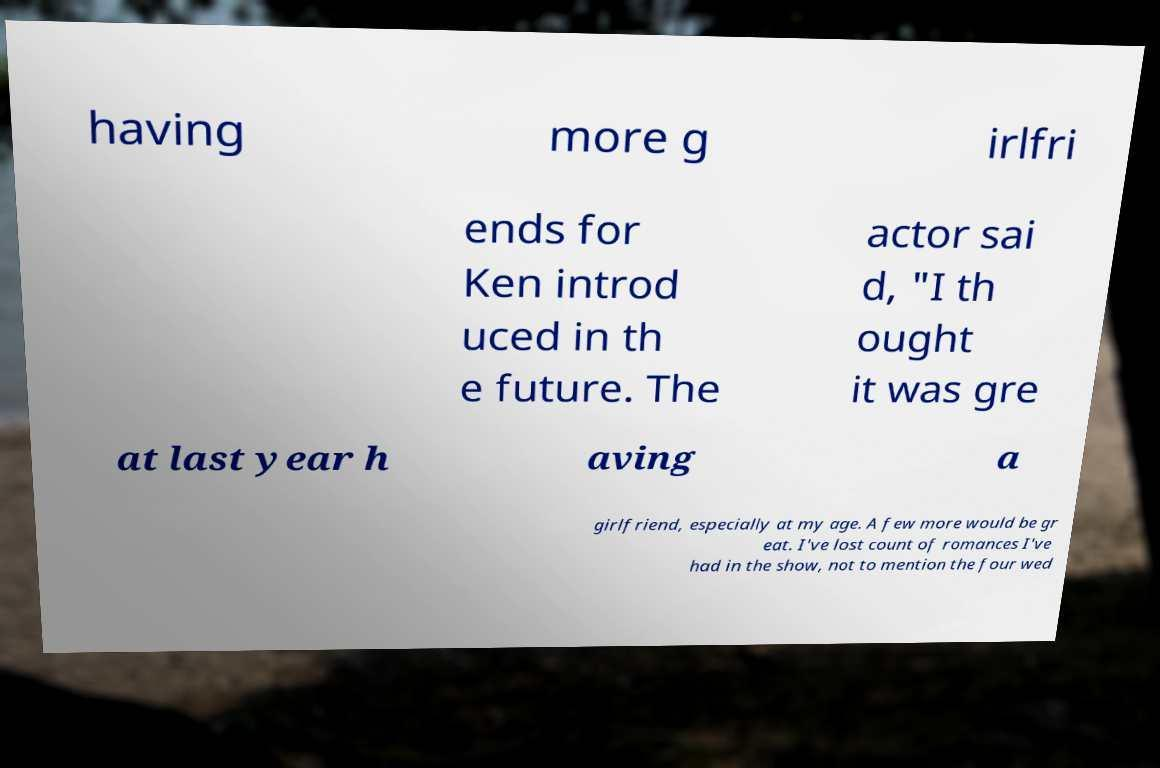Can you read and provide the text displayed in the image?This photo seems to have some interesting text. Can you extract and type it out for me? having more g irlfri ends for Ken introd uced in th e future. The actor sai d, "I th ought it was gre at last year h aving a girlfriend, especially at my age. A few more would be gr eat. I've lost count of romances I've had in the show, not to mention the four wed 